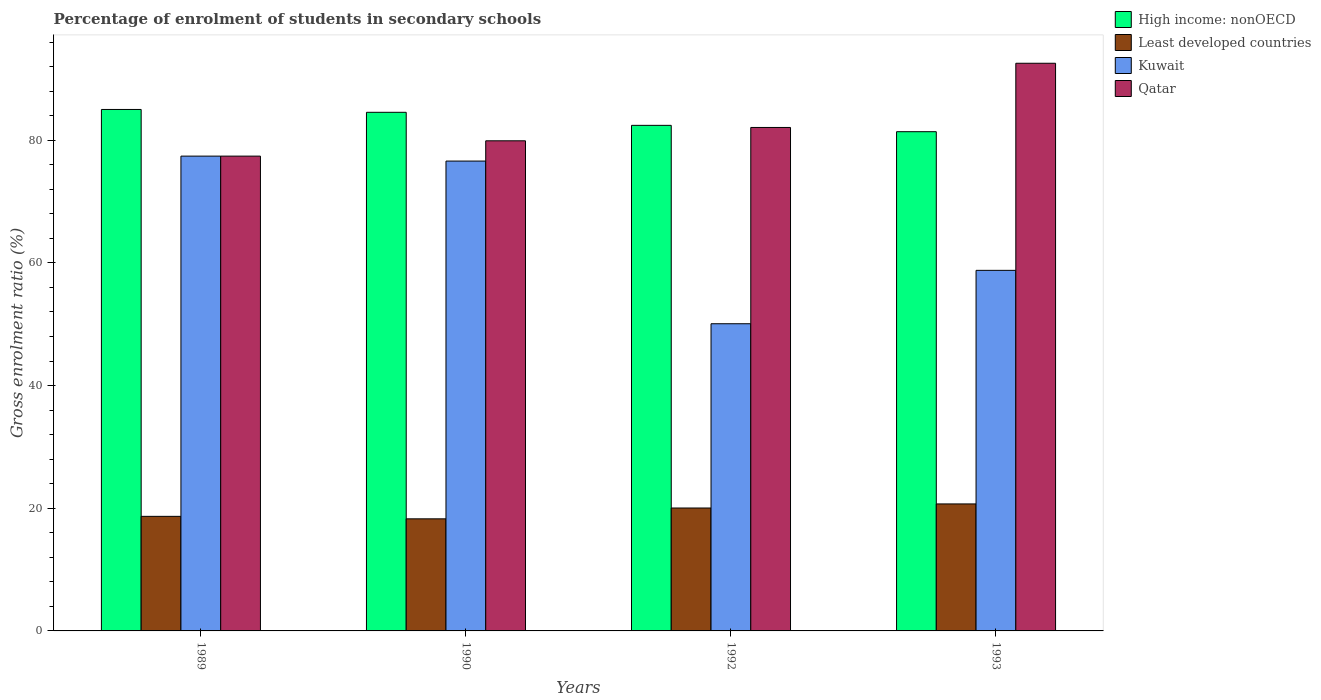How many groups of bars are there?
Your response must be concise. 4. Are the number of bars per tick equal to the number of legend labels?
Provide a succinct answer. Yes. How many bars are there on the 4th tick from the left?
Offer a very short reply. 4. How many bars are there on the 3rd tick from the right?
Make the answer very short. 4. What is the label of the 4th group of bars from the left?
Your response must be concise. 1993. In how many cases, is the number of bars for a given year not equal to the number of legend labels?
Offer a very short reply. 0. What is the percentage of students enrolled in secondary schools in Qatar in 1990?
Make the answer very short. 79.9. Across all years, what is the maximum percentage of students enrolled in secondary schools in Qatar?
Keep it short and to the point. 92.54. Across all years, what is the minimum percentage of students enrolled in secondary schools in Least developed countries?
Provide a succinct answer. 18.27. In which year was the percentage of students enrolled in secondary schools in High income: nonOECD maximum?
Your response must be concise. 1989. What is the total percentage of students enrolled in secondary schools in Least developed countries in the graph?
Your answer should be compact. 77.69. What is the difference between the percentage of students enrolled in secondary schools in Qatar in 1990 and that in 1992?
Ensure brevity in your answer.  -2.17. What is the difference between the percentage of students enrolled in secondary schools in Kuwait in 1992 and the percentage of students enrolled in secondary schools in Qatar in 1990?
Provide a short and direct response. -29.82. What is the average percentage of students enrolled in secondary schools in Qatar per year?
Your answer should be compact. 82.98. In the year 1993, what is the difference between the percentage of students enrolled in secondary schools in Kuwait and percentage of students enrolled in secondary schools in High income: nonOECD?
Your response must be concise. -22.61. What is the ratio of the percentage of students enrolled in secondary schools in High income: nonOECD in 1992 to that in 1993?
Provide a succinct answer. 1.01. Is the difference between the percentage of students enrolled in secondary schools in Kuwait in 1989 and 1992 greater than the difference between the percentage of students enrolled in secondary schools in High income: nonOECD in 1989 and 1992?
Your answer should be compact. Yes. What is the difference between the highest and the second highest percentage of students enrolled in secondary schools in Qatar?
Your answer should be very brief. 10.47. What is the difference between the highest and the lowest percentage of students enrolled in secondary schools in Kuwait?
Your answer should be very brief. 27.33. What does the 4th bar from the left in 1989 represents?
Provide a short and direct response. Qatar. What does the 2nd bar from the right in 1993 represents?
Offer a terse response. Kuwait. How many bars are there?
Keep it short and to the point. 16. Are all the bars in the graph horizontal?
Keep it short and to the point. No. How many years are there in the graph?
Offer a very short reply. 4. What is the difference between two consecutive major ticks on the Y-axis?
Your answer should be very brief. 20. Are the values on the major ticks of Y-axis written in scientific E-notation?
Provide a succinct answer. No. Does the graph contain any zero values?
Your answer should be compact. No. Where does the legend appear in the graph?
Keep it short and to the point. Top right. How are the legend labels stacked?
Your answer should be compact. Vertical. What is the title of the graph?
Provide a succinct answer. Percentage of enrolment of students in secondary schools. What is the Gross enrolment ratio (%) in High income: nonOECD in 1989?
Provide a short and direct response. 85.01. What is the Gross enrolment ratio (%) of Least developed countries in 1989?
Your answer should be very brief. 18.68. What is the Gross enrolment ratio (%) in Kuwait in 1989?
Provide a short and direct response. 77.41. What is the Gross enrolment ratio (%) in Qatar in 1989?
Offer a very short reply. 77.4. What is the Gross enrolment ratio (%) in High income: nonOECD in 1990?
Your answer should be very brief. 84.55. What is the Gross enrolment ratio (%) of Least developed countries in 1990?
Provide a succinct answer. 18.27. What is the Gross enrolment ratio (%) in Kuwait in 1990?
Offer a terse response. 76.6. What is the Gross enrolment ratio (%) of Qatar in 1990?
Ensure brevity in your answer.  79.9. What is the Gross enrolment ratio (%) of High income: nonOECD in 1992?
Provide a short and direct response. 82.42. What is the Gross enrolment ratio (%) in Least developed countries in 1992?
Keep it short and to the point. 20.04. What is the Gross enrolment ratio (%) of Kuwait in 1992?
Make the answer very short. 50.08. What is the Gross enrolment ratio (%) in Qatar in 1992?
Provide a succinct answer. 82.08. What is the Gross enrolment ratio (%) in High income: nonOECD in 1993?
Make the answer very short. 81.39. What is the Gross enrolment ratio (%) of Least developed countries in 1993?
Ensure brevity in your answer.  20.7. What is the Gross enrolment ratio (%) of Kuwait in 1993?
Your answer should be very brief. 58.78. What is the Gross enrolment ratio (%) in Qatar in 1993?
Your answer should be very brief. 92.54. Across all years, what is the maximum Gross enrolment ratio (%) in High income: nonOECD?
Your response must be concise. 85.01. Across all years, what is the maximum Gross enrolment ratio (%) in Least developed countries?
Make the answer very short. 20.7. Across all years, what is the maximum Gross enrolment ratio (%) in Kuwait?
Make the answer very short. 77.41. Across all years, what is the maximum Gross enrolment ratio (%) of Qatar?
Give a very brief answer. 92.54. Across all years, what is the minimum Gross enrolment ratio (%) in High income: nonOECD?
Your answer should be compact. 81.39. Across all years, what is the minimum Gross enrolment ratio (%) of Least developed countries?
Ensure brevity in your answer.  18.27. Across all years, what is the minimum Gross enrolment ratio (%) in Kuwait?
Provide a succinct answer. 50.08. Across all years, what is the minimum Gross enrolment ratio (%) in Qatar?
Your response must be concise. 77.4. What is the total Gross enrolment ratio (%) in High income: nonOECD in the graph?
Provide a short and direct response. 333.37. What is the total Gross enrolment ratio (%) in Least developed countries in the graph?
Keep it short and to the point. 77.69. What is the total Gross enrolment ratio (%) of Kuwait in the graph?
Keep it short and to the point. 262.87. What is the total Gross enrolment ratio (%) in Qatar in the graph?
Provide a short and direct response. 331.93. What is the difference between the Gross enrolment ratio (%) in High income: nonOECD in 1989 and that in 1990?
Ensure brevity in your answer.  0.46. What is the difference between the Gross enrolment ratio (%) in Least developed countries in 1989 and that in 1990?
Provide a succinct answer. 0.41. What is the difference between the Gross enrolment ratio (%) in Kuwait in 1989 and that in 1990?
Offer a very short reply. 0.81. What is the difference between the Gross enrolment ratio (%) of Qatar in 1989 and that in 1990?
Offer a terse response. -2.5. What is the difference between the Gross enrolment ratio (%) in High income: nonOECD in 1989 and that in 1992?
Offer a terse response. 2.59. What is the difference between the Gross enrolment ratio (%) of Least developed countries in 1989 and that in 1992?
Give a very brief answer. -1.36. What is the difference between the Gross enrolment ratio (%) of Kuwait in 1989 and that in 1992?
Offer a very short reply. 27.33. What is the difference between the Gross enrolment ratio (%) in Qatar in 1989 and that in 1992?
Offer a terse response. -4.67. What is the difference between the Gross enrolment ratio (%) in High income: nonOECD in 1989 and that in 1993?
Offer a terse response. 3.62. What is the difference between the Gross enrolment ratio (%) in Least developed countries in 1989 and that in 1993?
Your answer should be very brief. -2.02. What is the difference between the Gross enrolment ratio (%) of Kuwait in 1989 and that in 1993?
Keep it short and to the point. 18.62. What is the difference between the Gross enrolment ratio (%) in Qatar in 1989 and that in 1993?
Your response must be concise. -15.14. What is the difference between the Gross enrolment ratio (%) in High income: nonOECD in 1990 and that in 1992?
Provide a succinct answer. 2.13. What is the difference between the Gross enrolment ratio (%) of Least developed countries in 1990 and that in 1992?
Your answer should be compact. -1.76. What is the difference between the Gross enrolment ratio (%) of Kuwait in 1990 and that in 1992?
Your response must be concise. 26.52. What is the difference between the Gross enrolment ratio (%) in Qatar in 1990 and that in 1992?
Offer a terse response. -2.17. What is the difference between the Gross enrolment ratio (%) of High income: nonOECD in 1990 and that in 1993?
Offer a very short reply. 3.16. What is the difference between the Gross enrolment ratio (%) in Least developed countries in 1990 and that in 1993?
Offer a terse response. -2.43. What is the difference between the Gross enrolment ratio (%) of Kuwait in 1990 and that in 1993?
Keep it short and to the point. 17.82. What is the difference between the Gross enrolment ratio (%) in Qatar in 1990 and that in 1993?
Offer a very short reply. -12.64. What is the difference between the Gross enrolment ratio (%) in High income: nonOECD in 1992 and that in 1993?
Offer a terse response. 1.03. What is the difference between the Gross enrolment ratio (%) of Least developed countries in 1992 and that in 1993?
Your answer should be very brief. -0.67. What is the difference between the Gross enrolment ratio (%) in Kuwait in 1992 and that in 1993?
Your answer should be compact. -8.7. What is the difference between the Gross enrolment ratio (%) in Qatar in 1992 and that in 1993?
Ensure brevity in your answer.  -10.47. What is the difference between the Gross enrolment ratio (%) of High income: nonOECD in 1989 and the Gross enrolment ratio (%) of Least developed countries in 1990?
Your answer should be compact. 66.74. What is the difference between the Gross enrolment ratio (%) of High income: nonOECD in 1989 and the Gross enrolment ratio (%) of Kuwait in 1990?
Give a very brief answer. 8.41. What is the difference between the Gross enrolment ratio (%) in High income: nonOECD in 1989 and the Gross enrolment ratio (%) in Qatar in 1990?
Make the answer very short. 5.11. What is the difference between the Gross enrolment ratio (%) of Least developed countries in 1989 and the Gross enrolment ratio (%) of Kuwait in 1990?
Keep it short and to the point. -57.92. What is the difference between the Gross enrolment ratio (%) in Least developed countries in 1989 and the Gross enrolment ratio (%) in Qatar in 1990?
Keep it short and to the point. -61.22. What is the difference between the Gross enrolment ratio (%) of Kuwait in 1989 and the Gross enrolment ratio (%) of Qatar in 1990?
Provide a succinct answer. -2.5. What is the difference between the Gross enrolment ratio (%) in High income: nonOECD in 1989 and the Gross enrolment ratio (%) in Least developed countries in 1992?
Keep it short and to the point. 64.97. What is the difference between the Gross enrolment ratio (%) of High income: nonOECD in 1989 and the Gross enrolment ratio (%) of Kuwait in 1992?
Offer a very short reply. 34.93. What is the difference between the Gross enrolment ratio (%) of High income: nonOECD in 1989 and the Gross enrolment ratio (%) of Qatar in 1992?
Offer a very short reply. 2.93. What is the difference between the Gross enrolment ratio (%) in Least developed countries in 1989 and the Gross enrolment ratio (%) in Kuwait in 1992?
Your response must be concise. -31.4. What is the difference between the Gross enrolment ratio (%) in Least developed countries in 1989 and the Gross enrolment ratio (%) in Qatar in 1992?
Provide a succinct answer. -63.4. What is the difference between the Gross enrolment ratio (%) of Kuwait in 1989 and the Gross enrolment ratio (%) of Qatar in 1992?
Offer a terse response. -4.67. What is the difference between the Gross enrolment ratio (%) in High income: nonOECD in 1989 and the Gross enrolment ratio (%) in Least developed countries in 1993?
Your response must be concise. 64.31. What is the difference between the Gross enrolment ratio (%) of High income: nonOECD in 1989 and the Gross enrolment ratio (%) of Kuwait in 1993?
Your response must be concise. 26.23. What is the difference between the Gross enrolment ratio (%) of High income: nonOECD in 1989 and the Gross enrolment ratio (%) of Qatar in 1993?
Ensure brevity in your answer.  -7.53. What is the difference between the Gross enrolment ratio (%) in Least developed countries in 1989 and the Gross enrolment ratio (%) in Kuwait in 1993?
Your answer should be very brief. -40.1. What is the difference between the Gross enrolment ratio (%) in Least developed countries in 1989 and the Gross enrolment ratio (%) in Qatar in 1993?
Ensure brevity in your answer.  -73.86. What is the difference between the Gross enrolment ratio (%) in Kuwait in 1989 and the Gross enrolment ratio (%) in Qatar in 1993?
Make the answer very short. -15.14. What is the difference between the Gross enrolment ratio (%) in High income: nonOECD in 1990 and the Gross enrolment ratio (%) in Least developed countries in 1992?
Give a very brief answer. 64.51. What is the difference between the Gross enrolment ratio (%) of High income: nonOECD in 1990 and the Gross enrolment ratio (%) of Kuwait in 1992?
Your answer should be compact. 34.47. What is the difference between the Gross enrolment ratio (%) in High income: nonOECD in 1990 and the Gross enrolment ratio (%) in Qatar in 1992?
Make the answer very short. 2.47. What is the difference between the Gross enrolment ratio (%) in Least developed countries in 1990 and the Gross enrolment ratio (%) in Kuwait in 1992?
Your answer should be very brief. -31.81. What is the difference between the Gross enrolment ratio (%) in Least developed countries in 1990 and the Gross enrolment ratio (%) in Qatar in 1992?
Offer a very short reply. -63.8. What is the difference between the Gross enrolment ratio (%) in Kuwait in 1990 and the Gross enrolment ratio (%) in Qatar in 1992?
Your response must be concise. -5.48. What is the difference between the Gross enrolment ratio (%) of High income: nonOECD in 1990 and the Gross enrolment ratio (%) of Least developed countries in 1993?
Your answer should be very brief. 63.84. What is the difference between the Gross enrolment ratio (%) in High income: nonOECD in 1990 and the Gross enrolment ratio (%) in Kuwait in 1993?
Your answer should be compact. 25.76. What is the difference between the Gross enrolment ratio (%) in High income: nonOECD in 1990 and the Gross enrolment ratio (%) in Qatar in 1993?
Give a very brief answer. -8. What is the difference between the Gross enrolment ratio (%) in Least developed countries in 1990 and the Gross enrolment ratio (%) in Kuwait in 1993?
Provide a succinct answer. -40.51. What is the difference between the Gross enrolment ratio (%) in Least developed countries in 1990 and the Gross enrolment ratio (%) in Qatar in 1993?
Provide a succinct answer. -74.27. What is the difference between the Gross enrolment ratio (%) of Kuwait in 1990 and the Gross enrolment ratio (%) of Qatar in 1993?
Provide a short and direct response. -15.95. What is the difference between the Gross enrolment ratio (%) of High income: nonOECD in 1992 and the Gross enrolment ratio (%) of Least developed countries in 1993?
Ensure brevity in your answer.  61.72. What is the difference between the Gross enrolment ratio (%) of High income: nonOECD in 1992 and the Gross enrolment ratio (%) of Kuwait in 1993?
Your response must be concise. 23.64. What is the difference between the Gross enrolment ratio (%) of High income: nonOECD in 1992 and the Gross enrolment ratio (%) of Qatar in 1993?
Your response must be concise. -10.12. What is the difference between the Gross enrolment ratio (%) of Least developed countries in 1992 and the Gross enrolment ratio (%) of Kuwait in 1993?
Ensure brevity in your answer.  -38.75. What is the difference between the Gross enrolment ratio (%) of Least developed countries in 1992 and the Gross enrolment ratio (%) of Qatar in 1993?
Provide a short and direct response. -72.51. What is the difference between the Gross enrolment ratio (%) in Kuwait in 1992 and the Gross enrolment ratio (%) in Qatar in 1993?
Provide a succinct answer. -42.46. What is the average Gross enrolment ratio (%) in High income: nonOECD per year?
Your response must be concise. 83.34. What is the average Gross enrolment ratio (%) in Least developed countries per year?
Make the answer very short. 19.42. What is the average Gross enrolment ratio (%) in Kuwait per year?
Your response must be concise. 65.72. What is the average Gross enrolment ratio (%) of Qatar per year?
Keep it short and to the point. 82.98. In the year 1989, what is the difference between the Gross enrolment ratio (%) in High income: nonOECD and Gross enrolment ratio (%) in Least developed countries?
Keep it short and to the point. 66.33. In the year 1989, what is the difference between the Gross enrolment ratio (%) of High income: nonOECD and Gross enrolment ratio (%) of Kuwait?
Keep it short and to the point. 7.61. In the year 1989, what is the difference between the Gross enrolment ratio (%) of High income: nonOECD and Gross enrolment ratio (%) of Qatar?
Your answer should be compact. 7.61. In the year 1989, what is the difference between the Gross enrolment ratio (%) of Least developed countries and Gross enrolment ratio (%) of Kuwait?
Your answer should be very brief. -58.73. In the year 1989, what is the difference between the Gross enrolment ratio (%) in Least developed countries and Gross enrolment ratio (%) in Qatar?
Give a very brief answer. -58.73. In the year 1989, what is the difference between the Gross enrolment ratio (%) of Kuwait and Gross enrolment ratio (%) of Qatar?
Offer a very short reply. 0. In the year 1990, what is the difference between the Gross enrolment ratio (%) of High income: nonOECD and Gross enrolment ratio (%) of Least developed countries?
Give a very brief answer. 66.27. In the year 1990, what is the difference between the Gross enrolment ratio (%) of High income: nonOECD and Gross enrolment ratio (%) of Kuwait?
Keep it short and to the point. 7.95. In the year 1990, what is the difference between the Gross enrolment ratio (%) of High income: nonOECD and Gross enrolment ratio (%) of Qatar?
Your response must be concise. 4.65. In the year 1990, what is the difference between the Gross enrolment ratio (%) in Least developed countries and Gross enrolment ratio (%) in Kuwait?
Offer a terse response. -58.32. In the year 1990, what is the difference between the Gross enrolment ratio (%) of Least developed countries and Gross enrolment ratio (%) of Qatar?
Ensure brevity in your answer.  -61.63. In the year 1990, what is the difference between the Gross enrolment ratio (%) in Kuwait and Gross enrolment ratio (%) in Qatar?
Give a very brief answer. -3.3. In the year 1992, what is the difference between the Gross enrolment ratio (%) in High income: nonOECD and Gross enrolment ratio (%) in Least developed countries?
Make the answer very short. 62.38. In the year 1992, what is the difference between the Gross enrolment ratio (%) of High income: nonOECD and Gross enrolment ratio (%) of Kuwait?
Your response must be concise. 32.34. In the year 1992, what is the difference between the Gross enrolment ratio (%) of High income: nonOECD and Gross enrolment ratio (%) of Qatar?
Your answer should be very brief. 0.34. In the year 1992, what is the difference between the Gross enrolment ratio (%) in Least developed countries and Gross enrolment ratio (%) in Kuwait?
Provide a succinct answer. -30.04. In the year 1992, what is the difference between the Gross enrolment ratio (%) of Least developed countries and Gross enrolment ratio (%) of Qatar?
Ensure brevity in your answer.  -62.04. In the year 1992, what is the difference between the Gross enrolment ratio (%) of Kuwait and Gross enrolment ratio (%) of Qatar?
Give a very brief answer. -32. In the year 1993, what is the difference between the Gross enrolment ratio (%) of High income: nonOECD and Gross enrolment ratio (%) of Least developed countries?
Keep it short and to the point. 60.68. In the year 1993, what is the difference between the Gross enrolment ratio (%) in High income: nonOECD and Gross enrolment ratio (%) in Kuwait?
Your answer should be compact. 22.61. In the year 1993, what is the difference between the Gross enrolment ratio (%) in High income: nonOECD and Gross enrolment ratio (%) in Qatar?
Offer a terse response. -11.16. In the year 1993, what is the difference between the Gross enrolment ratio (%) in Least developed countries and Gross enrolment ratio (%) in Kuwait?
Your answer should be very brief. -38.08. In the year 1993, what is the difference between the Gross enrolment ratio (%) of Least developed countries and Gross enrolment ratio (%) of Qatar?
Ensure brevity in your answer.  -71.84. In the year 1993, what is the difference between the Gross enrolment ratio (%) of Kuwait and Gross enrolment ratio (%) of Qatar?
Provide a short and direct response. -33.76. What is the ratio of the Gross enrolment ratio (%) of High income: nonOECD in 1989 to that in 1990?
Your answer should be compact. 1.01. What is the ratio of the Gross enrolment ratio (%) in Least developed countries in 1989 to that in 1990?
Give a very brief answer. 1.02. What is the ratio of the Gross enrolment ratio (%) of Kuwait in 1989 to that in 1990?
Offer a terse response. 1.01. What is the ratio of the Gross enrolment ratio (%) in Qatar in 1989 to that in 1990?
Your answer should be very brief. 0.97. What is the ratio of the Gross enrolment ratio (%) of High income: nonOECD in 1989 to that in 1992?
Your response must be concise. 1.03. What is the ratio of the Gross enrolment ratio (%) of Least developed countries in 1989 to that in 1992?
Offer a terse response. 0.93. What is the ratio of the Gross enrolment ratio (%) of Kuwait in 1989 to that in 1992?
Offer a terse response. 1.55. What is the ratio of the Gross enrolment ratio (%) of Qatar in 1989 to that in 1992?
Offer a terse response. 0.94. What is the ratio of the Gross enrolment ratio (%) in High income: nonOECD in 1989 to that in 1993?
Make the answer very short. 1.04. What is the ratio of the Gross enrolment ratio (%) in Least developed countries in 1989 to that in 1993?
Your answer should be very brief. 0.9. What is the ratio of the Gross enrolment ratio (%) in Kuwait in 1989 to that in 1993?
Offer a terse response. 1.32. What is the ratio of the Gross enrolment ratio (%) in Qatar in 1989 to that in 1993?
Give a very brief answer. 0.84. What is the ratio of the Gross enrolment ratio (%) in High income: nonOECD in 1990 to that in 1992?
Give a very brief answer. 1.03. What is the ratio of the Gross enrolment ratio (%) of Least developed countries in 1990 to that in 1992?
Offer a terse response. 0.91. What is the ratio of the Gross enrolment ratio (%) of Kuwait in 1990 to that in 1992?
Your answer should be compact. 1.53. What is the ratio of the Gross enrolment ratio (%) in Qatar in 1990 to that in 1992?
Your answer should be very brief. 0.97. What is the ratio of the Gross enrolment ratio (%) of High income: nonOECD in 1990 to that in 1993?
Offer a very short reply. 1.04. What is the ratio of the Gross enrolment ratio (%) of Least developed countries in 1990 to that in 1993?
Make the answer very short. 0.88. What is the ratio of the Gross enrolment ratio (%) of Kuwait in 1990 to that in 1993?
Offer a very short reply. 1.3. What is the ratio of the Gross enrolment ratio (%) in Qatar in 1990 to that in 1993?
Offer a terse response. 0.86. What is the ratio of the Gross enrolment ratio (%) in High income: nonOECD in 1992 to that in 1993?
Ensure brevity in your answer.  1.01. What is the ratio of the Gross enrolment ratio (%) in Least developed countries in 1992 to that in 1993?
Your answer should be very brief. 0.97. What is the ratio of the Gross enrolment ratio (%) of Kuwait in 1992 to that in 1993?
Your answer should be very brief. 0.85. What is the ratio of the Gross enrolment ratio (%) of Qatar in 1992 to that in 1993?
Provide a short and direct response. 0.89. What is the difference between the highest and the second highest Gross enrolment ratio (%) in High income: nonOECD?
Provide a succinct answer. 0.46. What is the difference between the highest and the second highest Gross enrolment ratio (%) in Least developed countries?
Keep it short and to the point. 0.67. What is the difference between the highest and the second highest Gross enrolment ratio (%) of Kuwait?
Keep it short and to the point. 0.81. What is the difference between the highest and the second highest Gross enrolment ratio (%) of Qatar?
Keep it short and to the point. 10.47. What is the difference between the highest and the lowest Gross enrolment ratio (%) of High income: nonOECD?
Your answer should be very brief. 3.62. What is the difference between the highest and the lowest Gross enrolment ratio (%) in Least developed countries?
Keep it short and to the point. 2.43. What is the difference between the highest and the lowest Gross enrolment ratio (%) of Kuwait?
Make the answer very short. 27.33. What is the difference between the highest and the lowest Gross enrolment ratio (%) in Qatar?
Provide a short and direct response. 15.14. 